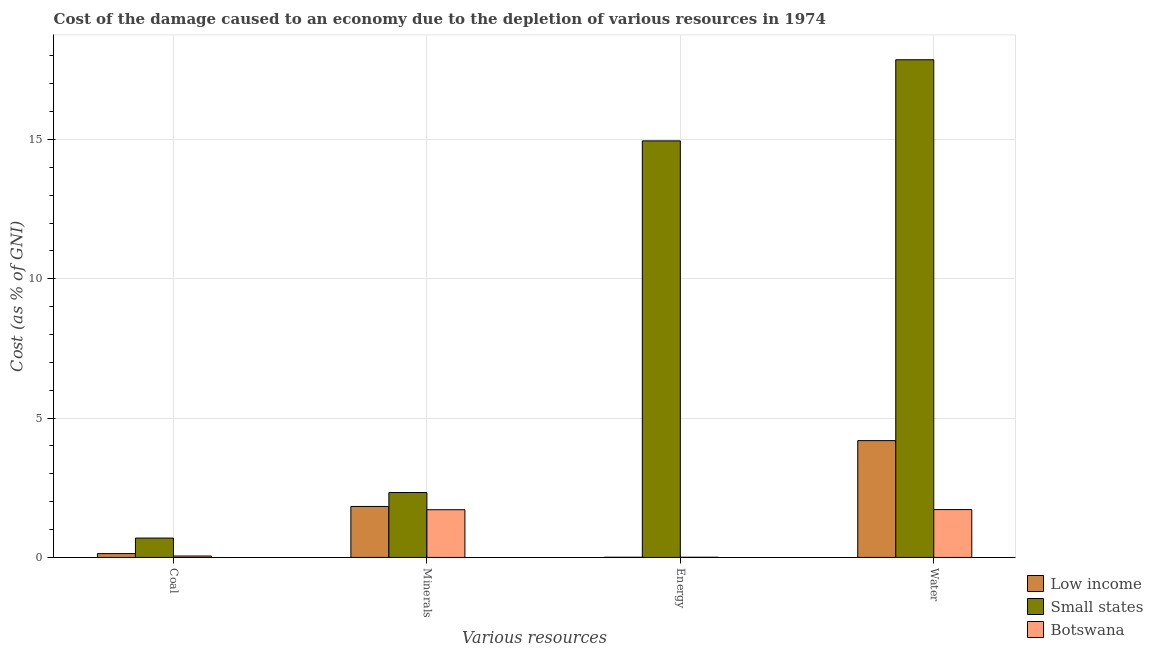How many different coloured bars are there?
Keep it short and to the point. 3. How many groups of bars are there?
Make the answer very short. 4. Are the number of bars per tick equal to the number of legend labels?
Keep it short and to the point. Yes. What is the label of the 4th group of bars from the left?
Your answer should be compact. Water. What is the cost of damage due to depletion of coal in Botswana?
Provide a short and direct response. 0.05. Across all countries, what is the maximum cost of damage due to depletion of energy?
Your response must be concise. 14.95. Across all countries, what is the minimum cost of damage due to depletion of coal?
Your answer should be very brief. 0.05. In which country was the cost of damage due to depletion of minerals maximum?
Make the answer very short. Small states. In which country was the cost of damage due to depletion of minerals minimum?
Give a very brief answer. Botswana. What is the total cost of damage due to depletion of minerals in the graph?
Make the answer very short. 5.87. What is the difference between the cost of damage due to depletion of energy in Low income and that in Botswana?
Provide a succinct answer. -0. What is the difference between the cost of damage due to depletion of energy in Botswana and the cost of damage due to depletion of water in Small states?
Make the answer very short. -17.86. What is the average cost of damage due to depletion of energy per country?
Give a very brief answer. 4.99. What is the difference between the cost of damage due to depletion of energy and cost of damage due to depletion of coal in Botswana?
Provide a short and direct response. -0.04. What is the ratio of the cost of damage due to depletion of water in Botswana to that in Small states?
Offer a terse response. 0.1. Is the cost of damage due to depletion of coal in Botswana less than that in Low income?
Your answer should be very brief. Yes. What is the difference between the highest and the second highest cost of damage due to depletion of energy?
Give a very brief answer. 14.94. What is the difference between the highest and the lowest cost of damage due to depletion of minerals?
Make the answer very short. 0.62. In how many countries, is the cost of damage due to depletion of water greater than the average cost of damage due to depletion of water taken over all countries?
Ensure brevity in your answer.  1. What does the 1st bar from the right in Energy represents?
Offer a terse response. Botswana. Are all the bars in the graph horizontal?
Ensure brevity in your answer.  No. How many countries are there in the graph?
Your answer should be compact. 3. What is the difference between two consecutive major ticks on the Y-axis?
Your response must be concise. 5. Are the values on the major ticks of Y-axis written in scientific E-notation?
Your answer should be compact. No. Does the graph contain any zero values?
Ensure brevity in your answer.  No. Does the graph contain grids?
Offer a terse response. Yes. Where does the legend appear in the graph?
Give a very brief answer. Bottom right. What is the title of the graph?
Your answer should be compact. Cost of the damage caused to an economy due to the depletion of various resources in 1974 . What is the label or title of the X-axis?
Your answer should be very brief. Various resources. What is the label or title of the Y-axis?
Provide a succinct answer. Cost (as % of GNI). What is the Cost (as % of GNI) in Low income in Coal?
Ensure brevity in your answer.  0.14. What is the Cost (as % of GNI) in Small states in Coal?
Ensure brevity in your answer.  0.69. What is the Cost (as % of GNI) of Botswana in Coal?
Provide a short and direct response. 0.05. What is the Cost (as % of GNI) of Low income in Minerals?
Make the answer very short. 1.83. What is the Cost (as % of GNI) in Small states in Minerals?
Keep it short and to the point. 2.33. What is the Cost (as % of GNI) in Botswana in Minerals?
Ensure brevity in your answer.  1.71. What is the Cost (as % of GNI) in Low income in Energy?
Make the answer very short. 0.01. What is the Cost (as % of GNI) of Small states in Energy?
Offer a terse response. 14.95. What is the Cost (as % of GNI) of Botswana in Energy?
Offer a very short reply. 0.01. What is the Cost (as % of GNI) of Low income in Water?
Your response must be concise. 4.19. What is the Cost (as % of GNI) in Small states in Water?
Provide a short and direct response. 17.86. What is the Cost (as % of GNI) in Botswana in Water?
Your answer should be compact. 1.72. Across all Various resources, what is the maximum Cost (as % of GNI) in Low income?
Offer a terse response. 4.19. Across all Various resources, what is the maximum Cost (as % of GNI) of Small states?
Your answer should be compact. 17.86. Across all Various resources, what is the maximum Cost (as % of GNI) in Botswana?
Keep it short and to the point. 1.72. Across all Various resources, what is the minimum Cost (as % of GNI) in Low income?
Your response must be concise. 0.01. Across all Various resources, what is the minimum Cost (as % of GNI) in Small states?
Your answer should be very brief. 0.69. Across all Various resources, what is the minimum Cost (as % of GNI) in Botswana?
Your answer should be very brief. 0.01. What is the total Cost (as % of GNI) of Low income in the graph?
Provide a succinct answer. 6.16. What is the total Cost (as % of GNI) in Small states in the graph?
Make the answer very short. 35.84. What is the total Cost (as % of GNI) in Botswana in the graph?
Provide a succinct answer. 3.48. What is the difference between the Cost (as % of GNI) of Low income in Coal and that in Minerals?
Offer a very short reply. -1.69. What is the difference between the Cost (as % of GNI) of Small states in Coal and that in Minerals?
Your answer should be compact. -1.63. What is the difference between the Cost (as % of GNI) in Botswana in Coal and that in Minerals?
Your answer should be compact. -1.66. What is the difference between the Cost (as % of GNI) in Low income in Coal and that in Energy?
Give a very brief answer. 0.13. What is the difference between the Cost (as % of GNI) of Small states in Coal and that in Energy?
Offer a very short reply. -14.26. What is the difference between the Cost (as % of GNI) in Botswana in Coal and that in Energy?
Make the answer very short. 0.04. What is the difference between the Cost (as % of GNI) of Low income in Coal and that in Water?
Offer a terse response. -4.05. What is the difference between the Cost (as % of GNI) of Small states in Coal and that in Water?
Your response must be concise. -17.17. What is the difference between the Cost (as % of GNI) in Botswana in Coal and that in Water?
Your answer should be compact. -1.67. What is the difference between the Cost (as % of GNI) in Low income in Minerals and that in Energy?
Give a very brief answer. 1.82. What is the difference between the Cost (as % of GNI) of Small states in Minerals and that in Energy?
Your answer should be very brief. -12.62. What is the difference between the Cost (as % of GNI) in Botswana in Minerals and that in Energy?
Provide a succinct answer. 1.71. What is the difference between the Cost (as % of GNI) in Low income in Minerals and that in Water?
Provide a short and direct response. -2.36. What is the difference between the Cost (as % of GNI) in Small states in Minerals and that in Water?
Give a very brief answer. -15.53. What is the difference between the Cost (as % of GNI) in Botswana in Minerals and that in Water?
Your answer should be very brief. -0.01. What is the difference between the Cost (as % of GNI) in Low income in Energy and that in Water?
Keep it short and to the point. -4.19. What is the difference between the Cost (as % of GNI) in Small states in Energy and that in Water?
Provide a short and direct response. -2.91. What is the difference between the Cost (as % of GNI) of Botswana in Energy and that in Water?
Give a very brief answer. -1.71. What is the difference between the Cost (as % of GNI) in Low income in Coal and the Cost (as % of GNI) in Small states in Minerals?
Your answer should be compact. -2.19. What is the difference between the Cost (as % of GNI) of Low income in Coal and the Cost (as % of GNI) of Botswana in Minerals?
Your answer should be very brief. -1.57. What is the difference between the Cost (as % of GNI) of Small states in Coal and the Cost (as % of GNI) of Botswana in Minerals?
Keep it short and to the point. -1.02. What is the difference between the Cost (as % of GNI) in Low income in Coal and the Cost (as % of GNI) in Small states in Energy?
Your answer should be compact. -14.81. What is the difference between the Cost (as % of GNI) in Low income in Coal and the Cost (as % of GNI) in Botswana in Energy?
Give a very brief answer. 0.13. What is the difference between the Cost (as % of GNI) of Small states in Coal and the Cost (as % of GNI) of Botswana in Energy?
Your response must be concise. 0.69. What is the difference between the Cost (as % of GNI) of Low income in Coal and the Cost (as % of GNI) of Small states in Water?
Keep it short and to the point. -17.72. What is the difference between the Cost (as % of GNI) of Low income in Coal and the Cost (as % of GNI) of Botswana in Water?
Your answer should be very brief. -1.58. What is the difference between the Cost (as % of GNI) in Small states in Coal and the Cost (as % of GNI) in Botswana in Water?
Make the answer very short. -1.02. What is the difference between the Cost (as % of GNI) in Low income in Minerals and the Cost (as % of GNI) in Small states in Energy?
Provide a short and direct response. -13.12. What is the difference between the Cost (as % of GNI) in Low income in Minerals and the Cost (as % of GNI) in Botswana in Energy?
Provide a short and direct response. 1.82. What is the difference between the Cost (as % of GNI) of Small states in Minerals and the Cost (as % of GNI) of Botswana in Energy?
Provide a short and direct response. 2.32. What is the difference between the Cost (as % of GNI) of Low income in Minerals and the Cost (as % of GNI) of Small states in Water?
Your answer should be very brief. -16.03. What is the difference between the Cost (as % of GNI) in Low income in Minerals and the Cost (as % of GNI) in Botswana in Water?
Make the answer very short. 0.11. What is the difference between the Cost (as % of GNI) of Small states in Minerals and the Cost (as % of GNI) of Botswana in Water?
Your answer should be very brief. 0.61. What is the difference between the Cost (as % of GNI) in Low income in Energy and the Cost (as % of GNI) in Small states in Water?
Ensure brevity in your answer.  -17.86. What is the difference between the Cost (as % of GNI) in Low income in Energy and the Cost (as % of GNI) in Botswana in Water?
Give a very brief answer. -1.71. What is the difference between the Cost (as % of GNI) of Small states in Energy and the Cost (as % of GNI) of Botswana in Water?
Your response must be concise. 13.23. What is the average Cost (as % of GNI) in Low income per Various resources?
Keep it short and to the point. 1.54. What is the average Cost (as % of GNI) in Small states per Various resources?
Give a very brief answer. 8.96. What is the average Cost (as % of GNI) in Botswana per Various resources?
Your answer should be very brief. 0.87. What is the difference between the Cost (as % of GNI) of Low income and Cost (as % of GNI) of Small states in Coal?
Your response must be concise. -0.56. What is the difference between the Cost (as % of GNI) in Low income and Cost (as % of GNI) in Botswana in Coal?
Your answer should be compact. 0.09. What is the difference between the Cost (as % of GNI) of Small states and Cost (as % of GNI) of Botswana in Coal?
Provide a succinct answer. 0.64. What is the difference between the Cost (as % of GNI) in Low income and Cost (as % of GNI) in Small states in Minerals?
Offer a terse response. -0.5. What is the difference between the Cost (as % of GNI) of Low income and Cost (as % of GNI) of Botswana in Minerals?
Your answer should be very brief. 0.12. What is the difference between the Cost (as % of GNI) in Small states and Cost (as % of GNI) in Botswana in Minerals?
Give a very brief answer. 0.62. What is the difference between the Cost (as % of GNI) in Low income and Cost (as % of GNI) in Small states in Energy?
Offer a terse response. -14.94. What is the difference between the Cost (as % of GNI) in Low income and Cost (as % of GNI) in Botswana in Energy?
Make the answer very short. -0. What is the difference between the Cost (as % of GNI) of Small states and Cost (as % of GNI) of Botswana in Energy?
Your answer should be compact. 14.94. What is the difference between the Cost (as % of GNI) in Low income and Cost (as % of GNI) in Small states in Water?
Provide a short and direct response. -13.67. What is the difference between the Cost (as % of GNI) of Low income and Cost (as % of GNI) of Botswana in Water?
Offer a very short reply. 2.47. What is the difference between the Cost (as % of GNI) of Small states and Cost (as % of GNI) of Botswana in Water?
Provide a short and direct response. 16.14. What is the ratio of the Cost (as % of GNI) in Low income in Coal to that in Minerals?
Offer a very short reply. 0.08. What is the ratio of the Cost (as % of GNI) of Small states in Coal to that in Minerals?
Keep it short and to the point. 0.3. What is the ratio of the Cost (as % of GNI) of Botswana in Coal to that in Minerals?
Your response must be concise. 0.03. What is the ratio of the Cost (as % of GNI) in Low income in Coal to that in Energy?
Ensure brevity in your answer.  23.6. What is the ratio of the Cost (as % of GNI) of Small states in Coal to that in Energy?
Your response must be concise. 0.05. What is the ratio of the Cost (as % of GNI) of Botswana in Coal to that in Energy?
Offer a terse response. 8.35. What is the ratio of the Cost (as % of GNI) in Low income in Coal to that in Water?
Your answer should be very brief. 0.03. What is the ratio of the Cost (as % of GNI) of Small states in Coal to that in Water?
Keep it short and to the point. 0.04. What is the ratio of the Cost (as % of GNI) in Botswana in Coal to that in Water?
Provide a succinct answer. 0.03. What is the ratio of the Cost (as % of GNI) in Low income in Minerals to that in Energy?
Provide a short and direct response. 314.37. What is the ratio of the Cost (as % of GNI) of Small states in Minerals to that in Energy?
Offer a terse response. 0.16. What is the ratio of the Cost (as % of GNI) in Botswana in Minerals to that in Energy?
Your answer should be compact. 285.12. What is the ratio of the Cost (as % of GNI) in Low income in Minerals to that in Water?
Give a very brief answer. 0.44. What is the ratio of the Cost (as % of GNI) of Small states in Minerals to that in Water?
Ensure brevity in your answer.  0.13. What is the ratio of the Cost (as % of GNI) of Botswana in Minerals to that in Water?
Make the answer very short. 1. What is the ratio of the Cost (as % of GNI) in Low income in Energy to that in Water?
Offer a terse response. 0. What is the ratio of the Cost (as % of GNI) in Small states in Energy to that in Water?
Keep it short and to the point. 0.84. What is the ratio of the Cost (as % of GNI) in Botswana in Energy to that in Water?
Ensure brevity in your answer.  0. What is the difference between the highest and the second highest Cost (as % of GNI) in Low income?
Give a very brief answer. 2.36. What is the difference between the highest and the second highest Cost (as % of GNI) of Small states?
Your answer should be very brief. 2.91. What is the difference between the highest and the second highest Cost (as % of GNI) of Botswana?
Your response must be concise. 0.01. What is the difference between the highest and the lowest Cost (as % of GNI) in Low income?
Give a very brief answer. 4.19. What is the difference between the highest and the lowest Cost (as % of GNI) of Small states?
Your answer should be very brief. 17.17. What is the difference between the highest and the lowest Cost (as % of GNI) in Botswana?
Your response must be concise. 1.71. 